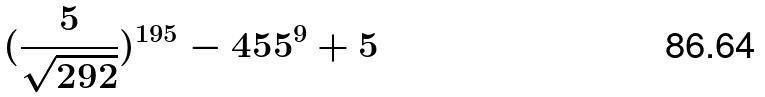<formula> <loc_0><loc_0><loc_500><loc_500>( \frac { 5 } { \sqrt { 2 9 2 } } ) ^ { 1 9 5 } - 4 5 5 ^ { 9 } + 5</formula> 